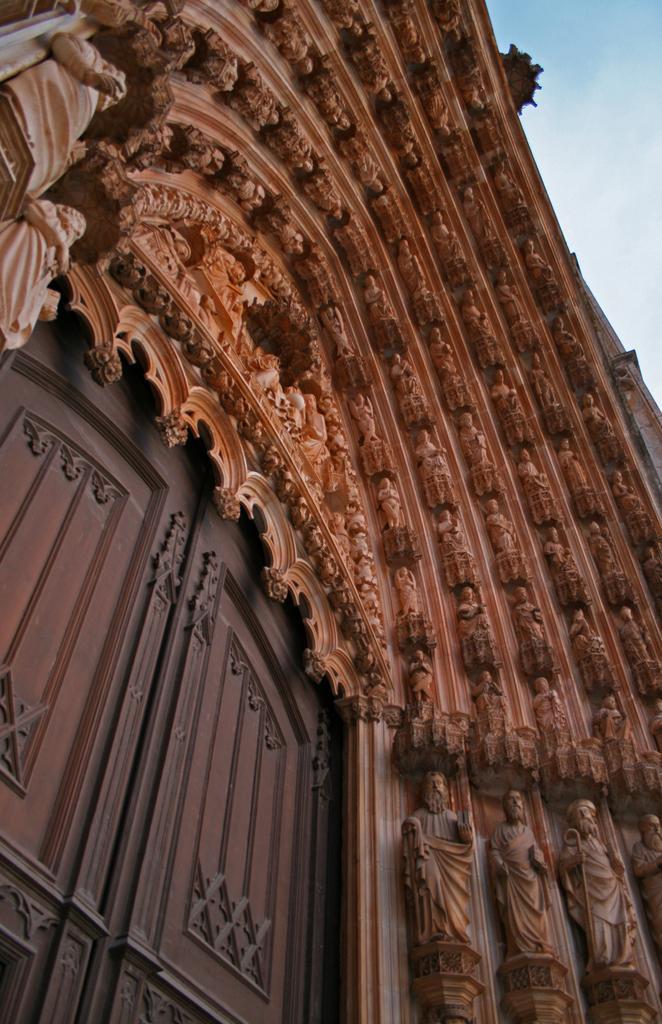Describe this image in one or two sentences. In this picture we can see door and statues. In the background of the image we can see the sky. 